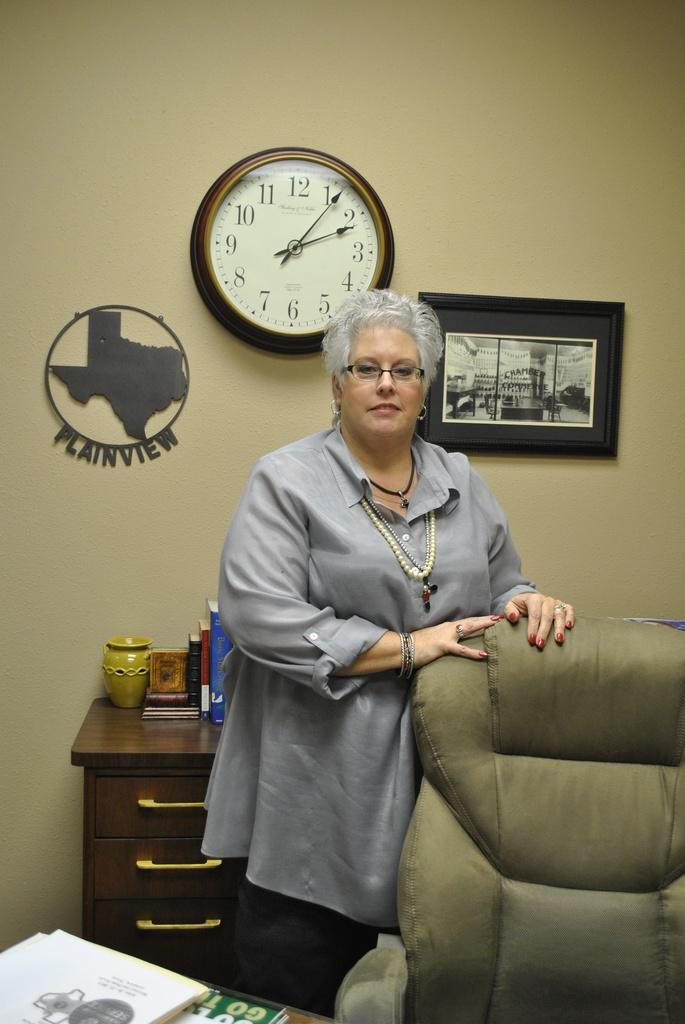<image>
Present a compact description of the photo's key features. A woman standing near a chair with a Plainview, Texas sign on the wall. 